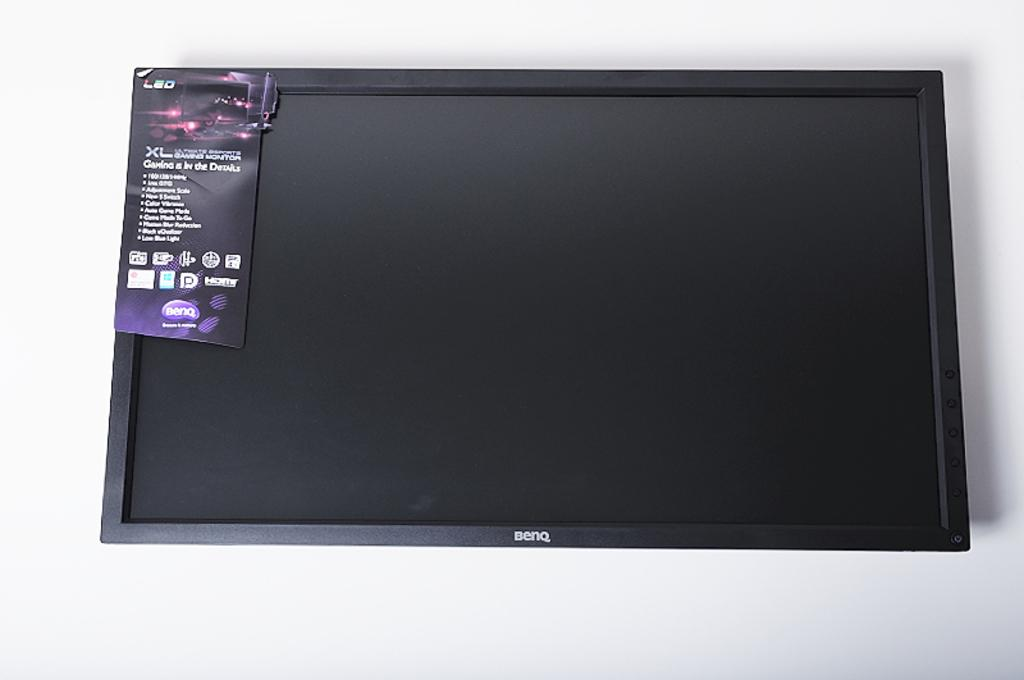<image>
Render a clear and concise summary of the photo. A Benq TV is on display against a white wall 